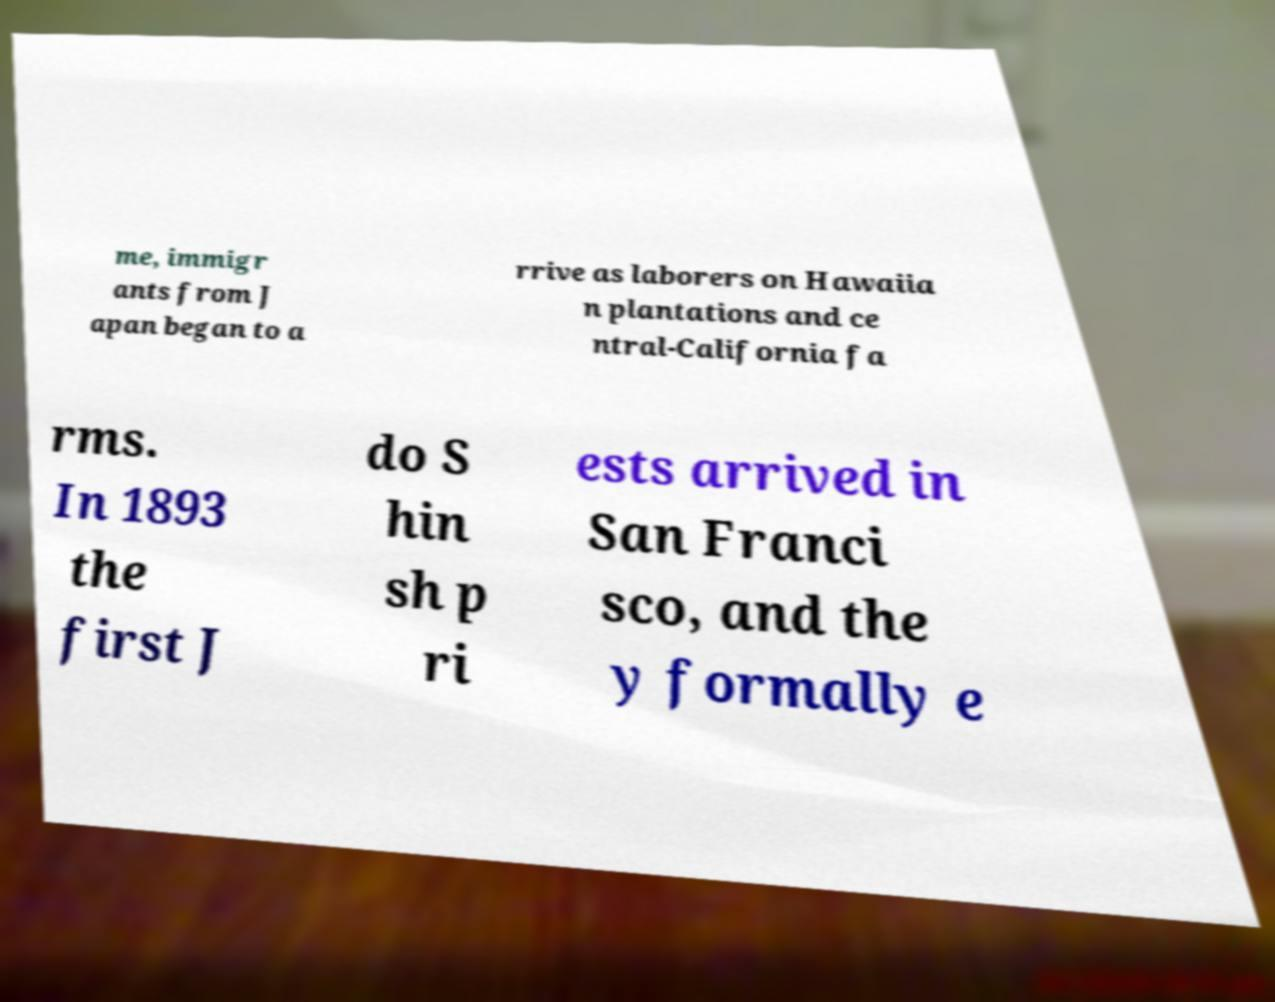Could you assist in decoding the text presented in this image and type it out clearly? me, immigr ants from J apan began to a rrive as laborers on Hawaiia n plantations and ce ntral-California fa rms. In 1893 the first J do S hin sh p ri ests arrived in San Franci sco, and the y formally e 